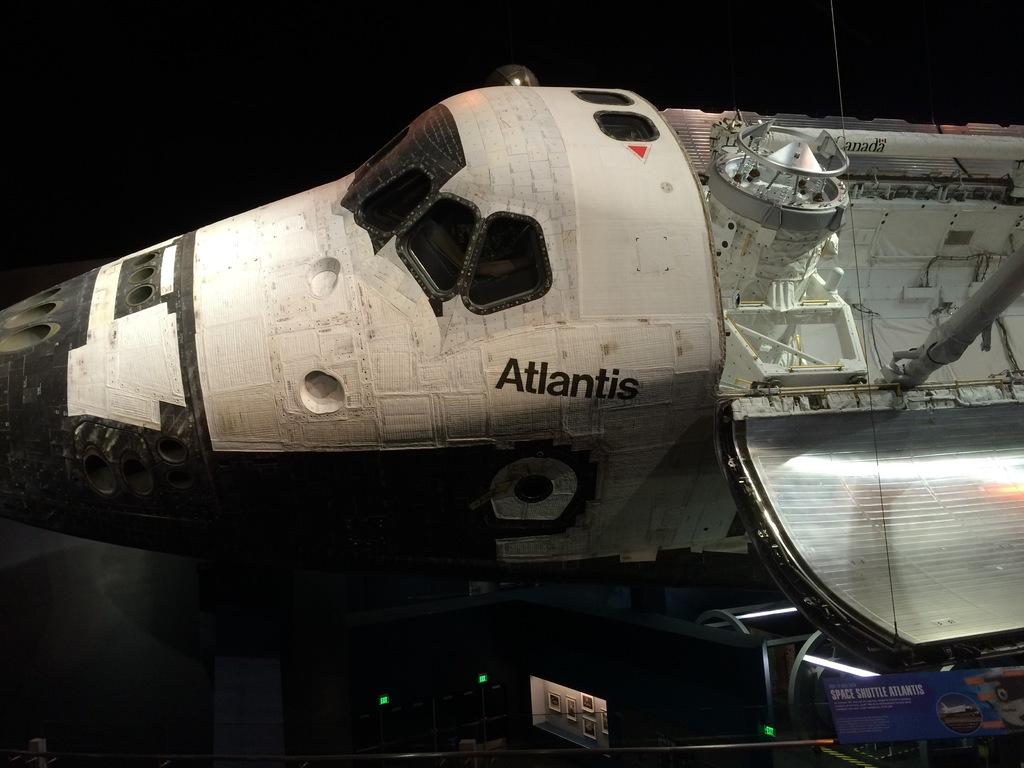Which space shuttle is that?
Give a very brief answer. Atlantis. 